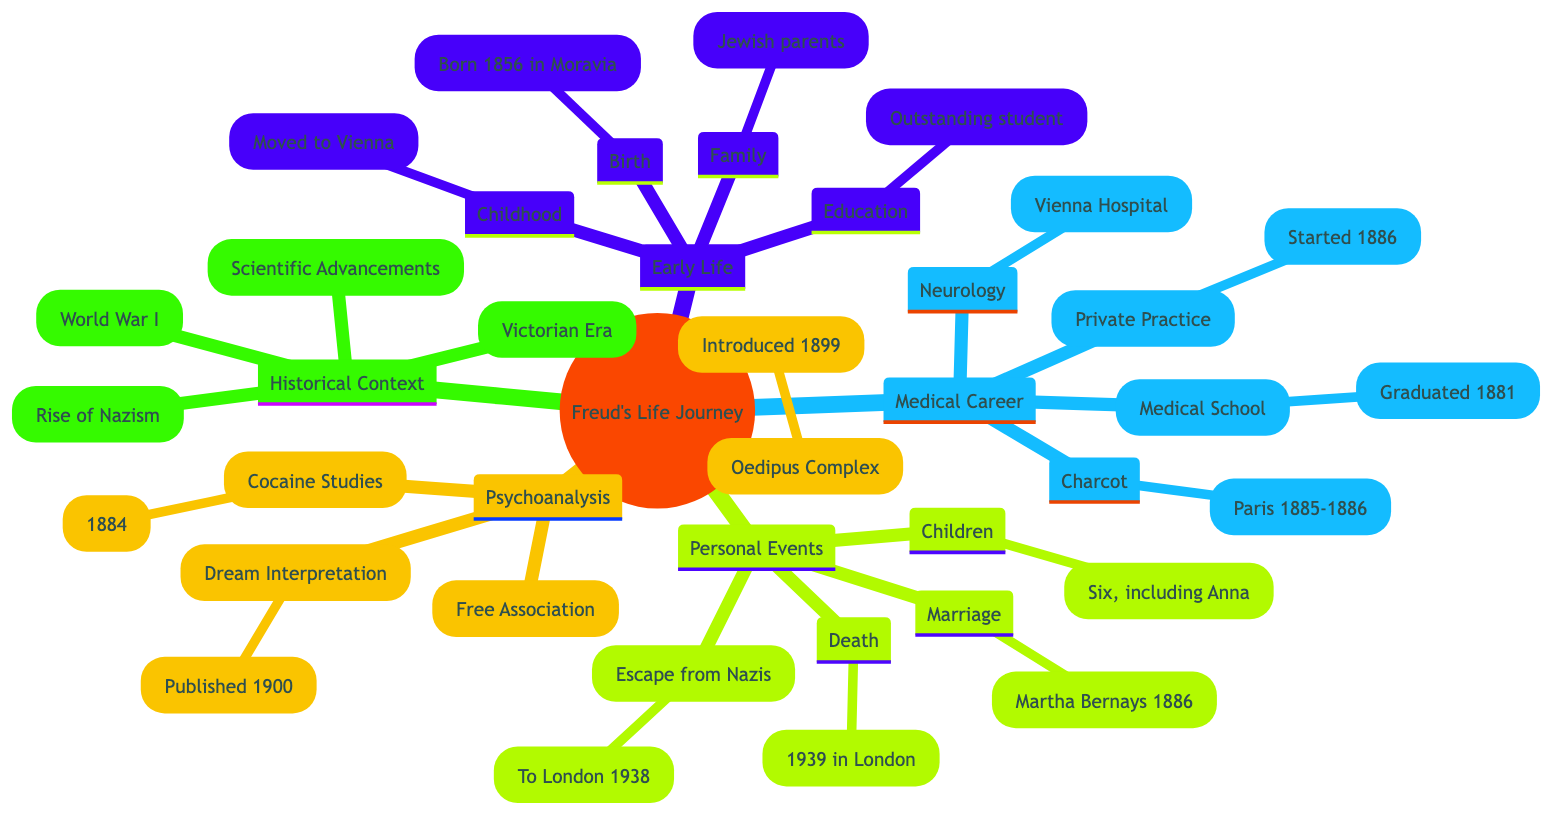What year was Freud born? The diagram indicates that Freud was born on May 6, 1856. Extracting just the year gives us 1856.
Answer: 1856 Who was Freud's mother? The diagram specifies that Freud's mother was Amalia Nathansohn, detailing her relationship as his mother.
Answer: Amalia Nathansohn What profession did Freud begin in 1886? In the "Medical and Academic Career" section, the diagram shows that Freud established a private practice in 1886 specializing in nervous disorders.
Answer: Private Practice What significant event happened to Freud in 1938? The "Key Personal Events" section details that Freud fled to London to escape Nazi annexation of Austria in 1938. This event is crucial to understanding his personal history during that time.
Answer: Escape from Nazis What concept did Freud introduce in 1899? The diagram states that Freud introduced the Oedipus Complex in 1899 under the "Psychoanalysis" section. This requires combining the date and the concept to answer correctly.
Answer: Oedipus Complex How many children did Freud have? According to the "Key Personal Events" segment, Freud had six children including Anna Freud. Therefore, the total number of his children is six.
Answer: Six What historical context influenced Freud's work during his early years? The "Historical Context" section mentions the Victorian Era, highlighting the period's strict moral values which were significant to Freud's early work.
Answer: Victorian Era What was Freud's relationship with Jean-Martin Charcot? The diagram reveals that Freud visited Salpêtrière Clinic in Paris to study under Jean-Martin Charcot in 1885-1886, establishing a mentorship or student-teacher relationship.
Answer: Student-Teacher Relation Which event led Freud and his family to flee Austria? "Rise of Nazism" is listed in the "Historical Context" section, indicating that this was the event that forced Freud and his family to escape Austria.
Answer: Rise of Nazism 